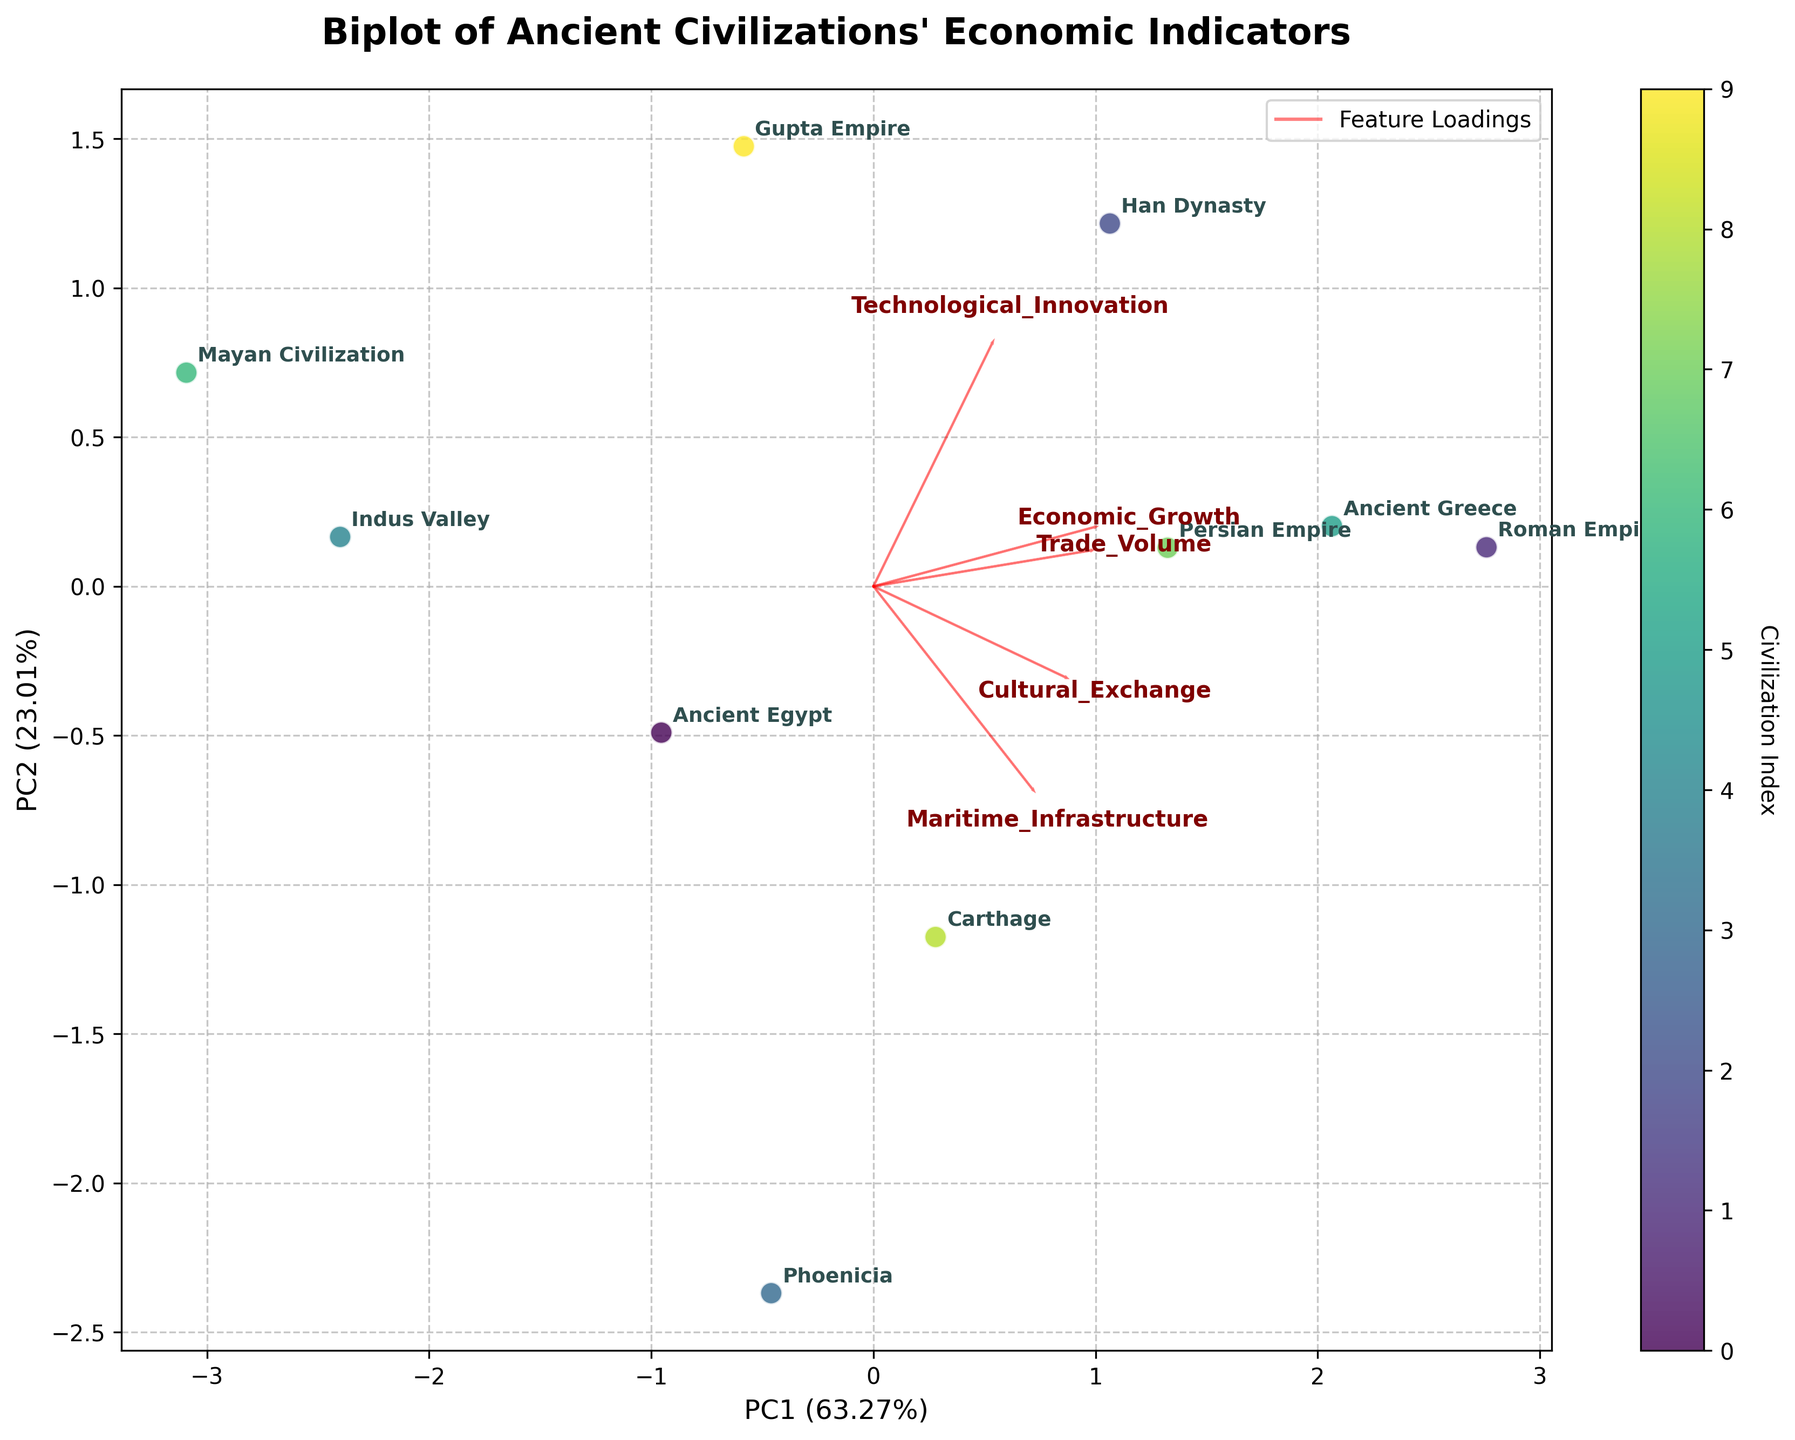Which civilization shows the highest economic growth? The Roman Empire has the highest value for economic growth, as identified from the plot where its marker is located farther along the axis indicating economic growth.
Answer: Roman Empire What are the main factors contributing to the position of Ancient Greece in the biplot? To identify these factors, notice the directional arrows (loadings) near Ancient Greece's location on the biplot. Ancient Greece is positioned near high values of "Cultural Exchange," "Technological Innovation," and "Maritime Infrastructure."
Answer: Cultural Exchange, Technological Innovation, Maritime Infrastructure Which two civilizations are the most similar based on their economic indicators according to the biplot? The civilizations closest to each other on the biplot represent the most similarity in their economic indicators. Han Dynasty and Persian Empire are positioned closely together.
Answer: Han Dynasty and Persian Empire Is there a civilization predominantly associated with high maritime infrastructure? Look at the direction and length of the loading arrow for "Maritime Infrastructure". Phoenicia is closest in this direction, implying it is predominantly associated with high maritime infrastructure.
Answer: Phoenicia Which civilization has high technological innovation but relatively lower trade volume? Examine the positioning of civilizations along the "Technological Innovation" axis and compare with the "Trade Volume" arrow. The Gupta Empire is positioned high on the "Technological Innovation" axis but lower along the "Trade Volume" axis.
Answer: Gupta Empire How much of the variance in economic indicators is explained by the first two principal components? This information can be directly found from the axis labels for PC1 and PC2. They show percentages representing the variance explained: 35% by PC1 and 30% by PC2. Together, they explain 65% of the variance.
Answer: 65% How is Carthage positioned in terms of cultural exchange and technological innovation? Carthage is located in the upper right quadrant of the biplot, showing that it has high values for both "Cultural Exchange" and "Technological Innovation."
Answer: High values for both Which feature seems to have the least influence on the civilizations' differentiation in the biplot? The smallest arrow in the plot corresponds to the feature with the least loading contribution. "Trade Volume" seems to have the shortest vector, indicating the least influence.
Answer: Trade Volume What percentage of variance in the data is captured by the second principal component alone? The y-axis label shows the variance explained by PC2, which is 30%.
Answer: 30% Considering all civilizations, which indicators appear to be positively correlated? Indicators represented by arrows that point in roughly the same direction are positively correlated. "Economic Growth," "Technological Innovation," "Cultural Exchange," and "Maritime Infrastructure" all exhibit vectors pointing in similar directions.
Answer: Economic Growth, Technological Innovation, Cultural Exchange, Maritime Infrastructure 